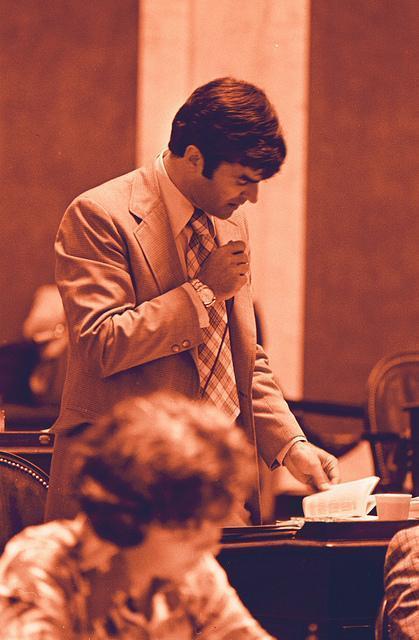How many cups are there?
Give a very brief answer. 1. How many people can you see?
Give a very brief answer. 3. How many chairs can be seen?
Give a very brief answer. 2. 